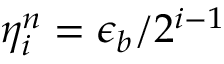<formula> <loc_0><loc_0><loc_500><loc_500>\eta _ { i } ^ { n } = \epsilon _ { b } / 2 ^ { i - 1 }</formula> 